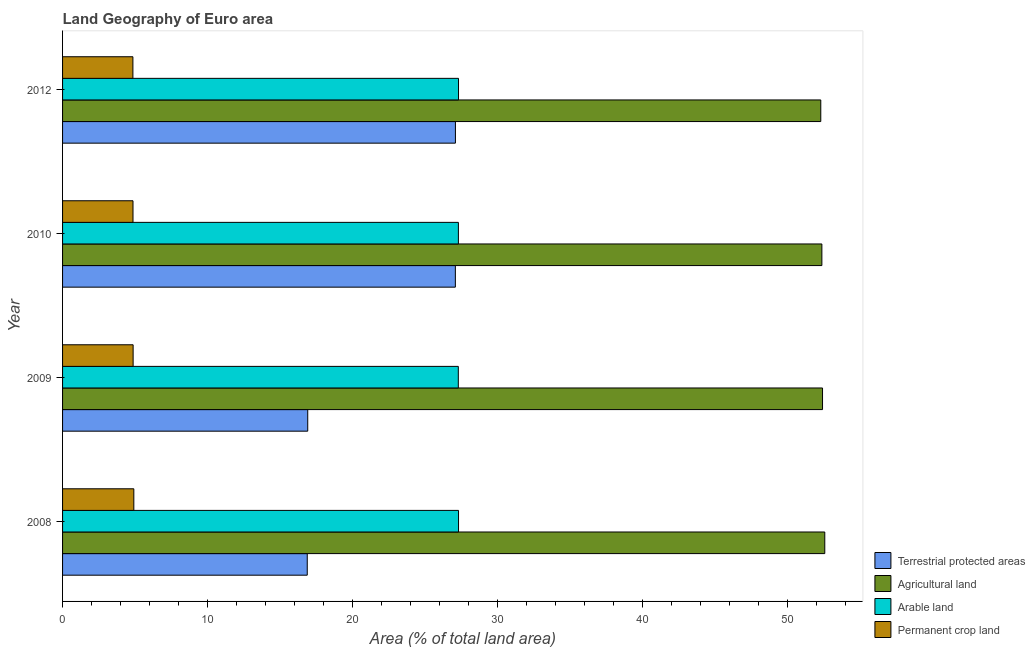How many groups of bars are there?
Your answer should be compact. 4. Are the number of bars per tick equal to the number of legend labels?
Offer a very short reply. Yes. What is the label of the 3rd group of bars from the top?
Offer a very short reply. 2009. What is the percentage of area under arable land in 2012?
Give a very brief answer. 27.31. Across all years, what is the maximum percentage of area under permanent crop land?
Your answer should be very brief. 4.92. Across all years, what is the minimum percentage of area under permanent crop land?
Your answer should be very brief. 4.85. In which year was the percentage of area under agricultural land maximum?
Your response must be concise. 2008. In which year was the percentage of area under permanent crop land minimum?
Your answer should be very brief. 2012. What is the total percentage of area under arable land in the graph?
Provide a short and direct response. 109.23. What is the difference between the percentage of area under permanent crop land in 2009 and that in 2010?
Your answer should be compact. 0.01. What is the difference between the percentage of area under arable land in 2009 and the percentage of land under terrestrial protection in 2012?
Offer a terse response. 0.2. What is the average percentage of land under terrestrial protection per year?
Your answer should be compact. 22. In the year 2010, what is the difference between the percentage of area under permanent crop land and percentage of area under agricultural land?
Offer a terse response. -47.52. What is the ratio of the percentage of area under arable land in 2008 to that in 2009?
Ensure brevity in your answer.  1. Is the percentage of area under permanent crop land in 2010 less than that in 2012?
Keep it short and to the point. No. What is the difference between the highest and the lowest percentage of area under permanent crop land?
Provide a succinct answer. 0.06. What does the 2nd bar from the top in 2009 represents?
Provide a succinct answer. Arable land. What does the 2nd bar from the bottom in 2008 represents?
Provide a succinct answer. Agricultural land. Is it the case that in every year, the sum of the percentage of land under terrestrial protection and percentage of area under agricultural land is greater than the percentage of area under arable land?
Make the answer very short. Yes. How many bars are there?
Offer a terse response. 16. How are the legend labels stacked?
Give a very brief answer. Vertical. What is the title of the graph?
Your answer should be very brief. Land Geography of Euro area. Does "Manufacturing" appear as one of the legend labels in the graph?
Make the answer very short. No. What is the label or title of the X-axis?
Ensure brevity in your answer.  Area (% of total land area). What is the Area (% of total land area) in Terrestrial protected areas in 2008?
Provide a short and direct response. 16.88. What is the Area (% of total land area) in Agricultural land in 2008?
Give a very brief answer. 52.58. What is the Area (% of total land area) in Arable land in 2008?
Offer a terse response. 27.31. What is the Area (% of total land area) in Permanent crop land in 2008?
Give a very brief answer. 4.92. What is the Area (% of total land area) in Terrestrial protected areas in 2009?
Ensure brevity in your answer.  16.91. What is the Area (% of total land area) of Agricultural land in 2009?
Ensure brevity in your answer.  52.42. What is the Area (% of total land area) in Arable land in 2009?
Offer a terse response. 27.3. What is the Area (% of total land area) of Permanent crop land in 2009?
Give a very brief answer. 4.87. What is the Area (% of total land area) of Terrestrial protected areas in 2010?
Provide a succinct answer. 27.1. What is the Area (% of total land area) of Agricultural land in 2010?
Provide a short and direct response. 52.38. What is the Area (% of total land area) in Arable land in 2010?
Provide a short and direct response. 27.3. What is the Area (% of total land area) of Permanent crop land in 2010?
Your answer should be compact. 4.86. What is the Area (% of total land area) in Terrestrial protected areas in 2012?
Offer a terse response. 27.1. What is the Area (% of total land area) in Agricultural land in 2012?
Your answer should be very brief. 52.3. What is the Area (% of total land area) of Arable land in 2012?
Offer a terse response. 27.31. What is the Area (% of total land area) in Permanent crop land in 2012?
Keep it short and to the point. 4.85. Across all years, what is the maximum Area (% of total land area) in Terrestrial protected areas?
Provide a succinct answer. 27.1. Across all years, what is the maximum Area (% of total land area) in Agricultural land?
Make the answer very short. 52.58. Across all years, what is the maximum Area (% of total land area) in Arable land?
Your response must be concise. 27.31. Across all years, what is the maximum Area (% of total land area) of Permanent crop land?
Provide a succinct answer. 4.92. Across all years, what is the minimum Area (% of total land area) in Terrestrial protected areas?
Your answer should be compact. 16.88. Across all years, what is the minimum Area (% of total land area) in Agricultural land?
Your answer should be compact. 52.3. Across all years, what is the minimum Area (% of total land area) of Arable land?
Ensure brevity in your answer.  27.3. Across all years, what is the minimum Area (% of total land area) of Permanent crop land?
Give a very brief answer. 4.85. What is the total Area (% of total land area) in Terrestrial protected areas in the graph?
Ensure brevity in your answer.  87.98. What is the total Area (% of total land area) of Agricultural land in the graph?
Give a very brief answer. 209.68. What is the total Area (% of total land area) of Arable land in the graph?
Offer a terse response. 109.23. What is the total Area (% of total land area) in Permanent crop land in the graph?
Make the answer very short. 19.5. What is the difference between the Area (% of total land area) in Terrestrial protected areas in 2008 and that in 2009?
Your answer should be very brief. -0.03. What is the difference between the Area (% of total land area) in Agricultural land in 2008 and that in 2009?
Offer a terse response. 0.16. What is the difference between the Area (% of total land area) in Arable land in 2008 and that in 2009?
Provide a succinct answer. 0.02. What is the difference between the Area (% of total land area) of Permanent crop land in 2008 and that in 2009?
Offer a terse response. 0.05. What is the difference between the Area (% of total land area) of Terrestrial protected areas in 2008 and that in 2010?
Ensure brevity in your answer.  -10.22. What is the difference between the Area (% of total land area) in Agricultural land in 2008 and that in 2010?
Provide a short and direct response. 0.2. What is the difference between the Area (% of total land area) in Arable land in 2008 and that in 2010?
Give a very brief answer. 0.01. What is the difference between the Area (% of total land area) in Permanent crop land in 2008 and that in 2010?
Make the answer very short. 0.06. What is the difference between the Area (% of total land area) in Terrestrial protected areas in 2008 and that in 2012?
Give a very brief answer. -10.22. What is the difference between the Area (% of total land area) of Agricultural land in 2008 and that in 2012?
Your response must be concise. 0.28. What is the difference between the Area (% of total land area) in Arable land in 2008 and that in 2012?
Provide a succinct answer. 0. What is the difference between the Area (% of total land area) in Permanent crop land in 2008 and that in 2012?
Ensure brevity in your answer.  0.06. What is the difference between the Area (% of total land area) in Terrestrial protected areas in 2009 and that in 2010?
Your response must be concise. -10.18. What is the difference between the Area (% of total land area) of Agricultural land in 2009 and that in 2010?
Ensure brevity in your answer.  0.05. What is the difference between the Area (% of total land area) in Arable land in 2009 and that in 2010?
Ensure brevity in your answer.  -0.01. What is the difference between the Area (% of total land area) in Permanent crop land in 2009 and that in 2010?
Provide a short and direct response. 0.01. What is the difference between the Area (% of total land area) in Terrestrial protected areas in 2009 and that in 2012?
Ensure brevity in your answer.  -10.19. What is the difference between the Area (% of total land area) of Agricultural land in 2009 and that in 2012?
Your answer should be very brief. 0.12. What is the difference between the Area (% of total land area) of Arable land in 2009 and that in 2012?
Offer a very short reply. -0.01. What is the difference between the Area (% of total land area) in Permanent crop land in 2009 and that in 2012?
Your answer should be very brief. 0.01. What is the difference between the Area (% of total land area) of Terrestrial protected areas in 2010 and that in 2012?
Keep it short and to the point. -0. What is the difference between the Area (% of total land area) in Agricultural land in 2010 and that in 2012?
Your answer should be compact. 0.08. What is the difference between the Area (% of total land area) in Arable land in 2010 and that in 2012?
Offer a terse response. -0.01. What is the difference between the Area (% of total land area) of Permanent crop land in 2010 and that in 2012?
Provide a succinct answer. 0.01. What is the difference between the Area (% of total land area) in Terrestrial protected areas in 2008 and the Area (% of total land area) in Agricultural land in 2009?
Your answer should be very brief. -35.55. What is the difference between the Area (% of total land area) of Terrestrial protected areas in 2008 and the Area (% of total land area) of Arable land in 2009?
Provide a succinct answer. -10.42. What is the difference between the Area (% of total land area) in Terrestrial protected areas in 2008 and the Area (% of total land area) in Permanent crop land in 2009?
Make the answer very short. 12.01. What is the difference between the Area (% of total land area) of Agricultural land in 2008 and the Area (% of total land area) of Arable land in 2009?
Make the answer very short. 25.28. What is the difference between the Area (% of total land area) in Agricultural land in 2008 and the Area (% of total land area) in Permanent crop land in 2009?
Offer a terse response. 47.71. What is the difference between the Area (% of total land area) of Arable land in 2008 and the Area (% of total land area) of Permanent crop land in 2009?
Keep it short and to the point. 22.45. What is the difference between the Area (% of total land area) of Terrestrial protected areas in 2008 and the Area (% of total land area) of Agricultural land in 2010?
Ensure brevity in your answer.  -35.5. What is the difference between the Area (% of total land area) of Terrestrial protected areas in 2008 and the Area (% of total land area) of Arable land in 2010?
Your answer should be compact. -10.43. What is the difference between the Area (% of total land area) of Terrestrial protected areas in 2008 and the Area (% of total land area) of Permanent crop land in 2010?
Ensure brevity in your answer.  12.02. What is the difference between the Area (% of total land area) in Agricultural land in 2008 and the Area (% of total land area) in Arable land in 2010?
Offer a terse response. 25.27. What is the difference between the Area (% of total land area) of Agricultural land in 2008 and the Area (% of total land area) of Permanent crop land in 2010?
Your response must be concise. 47.72. What is the difference between the Area (% of total land area) in Arable land in 2008 and the Area (% of total land area) in Permanent crop land in 2010?
Make the answer very short. 22.46. What is the difference between the Area (% of total land area) of Terrestrial protected areas in 2008 and the Area (% of total land area) of Agricultural land in 2012?
Make the answer very short. -35.42. What is the difference between the Area (% of total land area) of Terrestrial protected areas in 2008 and the Area (% of total land area) of Arable land in 2012?
Make the answer very short. -10.43. What is the difference between the Area (% of total land area) of Terrestrial protected areas in 2008 and the Area (% of total land area) of Permanent crop land in 2012?
Offer a terse response. 12.03. What is the difference between the Area (% of total land area) of Agricultural land in 2008 and the Area (% of total land area) of Arable land in 2012?
Offer a terse response. 25.27. What is the difference between the Area (% of total land area) of Agricultural land in 2008 and the Area (% of total land area) of Permanent crop land in 2012?
Keep it short and to the point. 47.73. What is the difference between the Area (% of total land area) in Arable land in 2008 and the Area (% of total land area) in Permanent crop land in 2012?
Keep it short and to the point. 22.46. What is the difference between the Area (% of total land area) of Terrestrial protected areas in 2009 and the Area (% of total land area) of Agricultural land in 2010?
Your response must be concise. -35.46. What is the difference between the Area (% of total land area) of Terrestrial protected areas in 2009 and the Area (% of total land area) of Arable land in 2010?
Ensure brevity in your answer.  -10.39. What is the difference between the Area (% of total land area) in Terrestrial protected areas in 2009 and the Area (% of total land area) in Permanent crop land in 2010?
Make the answer very short. 12.05. What is the difference between the Area (% of total land area) in Agricultural land in 2009 and the Area (% of total land area) in Arable land in 2010?
Your response must be concise. 25.12. What is the difference between the Area (% of total land area) of Agricultural land in 2009 and the Area (% of total land area) of Permanent crop land in 2010?
Make the answer very short. 47.56. What is the difference between the Area (% of total land area) in Arable land in 2009 and the Area (% of total land area) in Permanent crop land in 2010?
Your answer should be very brief. 22.44. What is the difference between the Area (% of total land area) in Terrestrial protected areas in 2009 and the Area (% of total land area) in Agricultural land in 2012?
Provide a short and direct response. -35.39. What is the difference between the Area (% of total land area) of Terrestrial protected areas in 2009 and the Area (% of total land area) of Arable land in 2012?
Offer a very short reply. -10.4. What is the difference between the Area (% of total land area) in Terrestrial protected areas in 2009 and the Area (% of total land area) in Permanent crop land in 2012?
Offer a very short reply. 12.06. What is the difference between the Area (% of total land area) in Agricultural land in 2009 and the Area (% of total land area) in Arable land in 2012?
Make the answer very short. 25.11. What is the difference between the Area (% of total land area) of Agricultural land in 2009 and the Area (% of total land area) of Permanent crop land in 2012?
Provide a succinct answer. 47.57. What is the difference between the Area (% of total land area) of Arable land in 2009 and the Area (% of total land area) of Permanent crop land in 2012?
Provide a short and direct response. 22.45. What is the difference between the Area (% of total land area) in Terrestrial protected areas in 2010 and the Area (% of total land area) in Agricultural land in 2012?
Keep it short and to the point. -25.21. What is the difference between the Area (% of total land area) in Terrestrial protected areas in 2010 and the Area (% of total land area) in Arable land in 2012?
Offer a terse response. -0.22. What is the difference between the Area (% of total land area) in Terrestrial protected areas in 2010 and the Area (% of total land area) in Permanent crop land in 2012?
Offer a terse response. 22.24. What is the difference between the Area (% of total land area) in Agricultural land in 2010 and the Area (% of total land area) in Arable land in 2012?
Offer a terse response. 25.06. What is the difference between the Area (% of total land area) in Agricultural land in 2010 and the Area (% of total land area) in Permanent crop land in 2012?
Keep it short and to the point. 47.52. What is the difference between the Area (% of total land area) of Arable land in 2010 and the Area (% of total land area) of Permanent crop land in 2012?
Provide a succinct answer. 22.45. What is the average Area (% of total land area) in Terrestrial protected areas per year?
Your response must be concise. 22. What is the average Area (% of total land area) in Agricultural land per year?
Your answer should be very brief. 52.42. What is the average Area (% of total land area) of Arable land per year?
Offer a terse response. 27.31. What is the average Area (% of total land area) in Permanent crop land per year?
Offer a terse response. 4.87. In the year 2008, what is the difference between the Area (% of total land area) in Terrestrial protected areas and Area (% of total land area) in Agricultural land?
Ensure brevity in your answer.  -35.7. In the year 2008, what is the difference between the Area (% of total land area) in Terrestrial protected areas and Area (% of total land area) in Arable land?
Ensure brevity in your answer.  -10.44. In the year 2008, what is the difference between the Area (% of total land area) of Terrestrial protected areas and Area (% of total land area) of Permanent crop land?
Provide a succinct answer. 11.96. In the year 2008, what is the difference between the Area (% of total land area) of Agricultural land and Area (% of total land area) of Arable land?
Your answer should be compact. 25.26. In the year 2008, what is the difference between the Area (% of total land area) in Agricultural land and Area (% of total land area) in Permanent crop land?
Your answer should be compact. 47.66. In the year 2008, what is the difference between the Area (% of total land area) in Arable land and Area (% of total land area) in Permanent crop land?
Give a very brief answer. 22.4. In the year 2009, what is the difference between the Area (% of total land area) of Terrestrial protected areas and Area (% of total land area) of Agricultural land?
Keep it short and to the point. -35.51. In the year 2009, what is the difference between the Area (% of total land area) in Terrestrial protected areas and Area (% of total land area) in Arable land?
Your response must be concise. -10.39. In the year 2009, what is the difference between the Area (% of total land area) in Terrestrial protected areas and Area (% of total land area) in Permanent crop land?
Ensure brevity in your answer.  12.04. In the year 2009, what is the difference between the Area (% of total land area) in Agricultural land and Area (% of total land area) in Arable land?
Offer a terse response. 25.12. In the year 2009, what is the difference between the Area (% of total land area) in Agricultural land and Area (% of total land area) in Permanent crop land?
Give a very brief answer. 47.56. In the year 2009, what is the difference between the Area (% of total land area) of Arable land and Area (% of total land area) of Permanent crop land?
Offer a terse response. 22.43. In the year 2010, what is the difference between the Area (% of total land area) of Terrestrial protected areas and Area (% of total land area) of Agricultural land?
Your response must be concise. -25.28. In the year 2010, what is the difference between the Area (% of total land area) in Terrestrial protected areas and Area (% of total land area) in Arable land?
Keep it short and to the point. -0.21. In the year 2010, what is the difference between the Area (% of total land area) in Terrestrial protected areas and Area (% of total land area) in Permanent crop land?
Offer a terse response. 22.24. In the year 2010, what is the difference between the Area (% of total land area) of Agricultural land and Area (% of total land area) of Arable land?
Give a very brief answer. 25.07. In the year 2010, what is the difference between the Area (% of total land area) in Agricultural land and Area (% of total land area) in Permanent crop land?
Your answer should be compact. 47.52. In the year 2010, what is the difference between the Area (% of total land area) of Arable land and Area (% of total land area) of Permanent crop land?
Make the answer very short. 22.44. In the year 2012, what is the difference between the Area (% of total land area) of Terrestrial protected areas and Area (% of total land area) of Agricultural land?
Give a very brief answer. -25.2. In the year 2012, what is the difference between the Area (% of total land area) of Terrestrial protected areas and Area (% of total land area) of Arable land?
Ensure brevity in your answer.  -0.21. In the year 2012, what is the difference between the Area (% of total land area) of Terrestrial protected areas and Area (% of total land area) of Permanent crop land?
Provide a short and direct response. 22.25. In the year 2012, what is the difference between the Area (% of total land area) in Agricultural land and Area (% of total land area) in Arable land?
Your answer should be very brief. 24.99. In the year 2012, what is the difference between the Area (% of total land area) of Agricultural land and Area (% of total land area) of Permanent crop land?
Provide a short and direct response. 47.45. In the year 2012, what is the difference between the Area (% of total land area) in Arable land and Area (% of total land area) in Permanent crop land?
Your answer should be very brief. 22.46. What is the ratio of the Area (% of total land area) of Agricultural land in 2008 to that in 2009?
Offer a terse response. 1. What is the ratio of the Area (% of total land area) of Permanent crop land in 2008 to that in 2009?
Ensure brevity in your answer.  1.01. What is the ratio of the Area (% of total land area) of Terrestrial protected areas in 2008 to that in 2010?
Offer a terse response. 0.62. What is the ratio of the Area (% of total land area) of Agricultural land in 2008 to that in 2010?
Make the answer very short. 1. What is the ratio of the Area (% of total land area) of Permanent crop land in 2008 to that in 2010?
Your response must be concise. 1.01. What is the ratio of the Area (% of total land area) in Terrestrial protected areas in 2008 to that in 2012?
Offer a terse response. 0.62. What is the ratio of the Area (% of total land area) of Terrestrial protected areas in 2009 to that in 2010?
Your answer should be compact. 0.62. What is the ratio of the Area (% of total land area) of Agricultural land in 2009 to that in 2010?
Your answer should be very brief. 1. What is the ratio of the Area (% of total land area) in Arable land in 2009 to that in 2010?
Provide a succinct answer. 1. What is the ratio of the Area (% of total land area) of Permanent crop land in 2009 to that in 2010?
Your response must be concise. 1. What is the ratio of the Area (% of total land area) in Terrestrial protected areas in 2009 to that in 2012?
Provide a succinct answer. 0.62. What is the ratio of the Area (% of total land area) in Agricultural land in 2009 to that in 2012?
Make the answer very short. 1. What is the ratio of the Area (% of total land area) of Arable land in 2009 to that in 2012?
Your response must be concise. 1. What is the ratio of the Area (% of total land area) in Permanent crop land in 2009 to that in 2012?
Offer a terse response. 1. What is the ratio of the Area (% of total land area) in Arable land in 2010 to that in 2012?
Ensure brevity in your answer.  1. What is the ratio of the Area (% of total land area) of Permanent crop land in 2010 to that in 2012?
Provide a short and direct response. 1. What is the difference between the highest and the second highest Area (% of total land area) of Terrestrial protected areas?
Provide a succinct answer. 0. What is the difference between the highest and the second highest Area (% of total land area) of Agricultural land?
Provide a short and direct response. 0.16. What is the difference between the highest and the second highest Area (% of total land area) of Arable land?
Your answer should be very brief. 0. What is the difference between the highest and the second highest Area (% of total land area) of Permanent crop land?
Provide a succinct answer. 0.05. What is the difference between the highest and the lowest Area (% of total land area) in Terrestrial protected areas?
Make the answer very short. 10.22. What is the difference between the highest and the lowest Area (% of total land area) of Agricultural land?
Give a very brief answer. 0.28. What is the difference between the highest and the lowest Area (% of total land area) in Arable land?
Your answer should be very brief. 0.02. What is the difference between the highest and the lowest Area (% of total land area) of Permanent crop land?
Your answer should be compact. 0.06. 